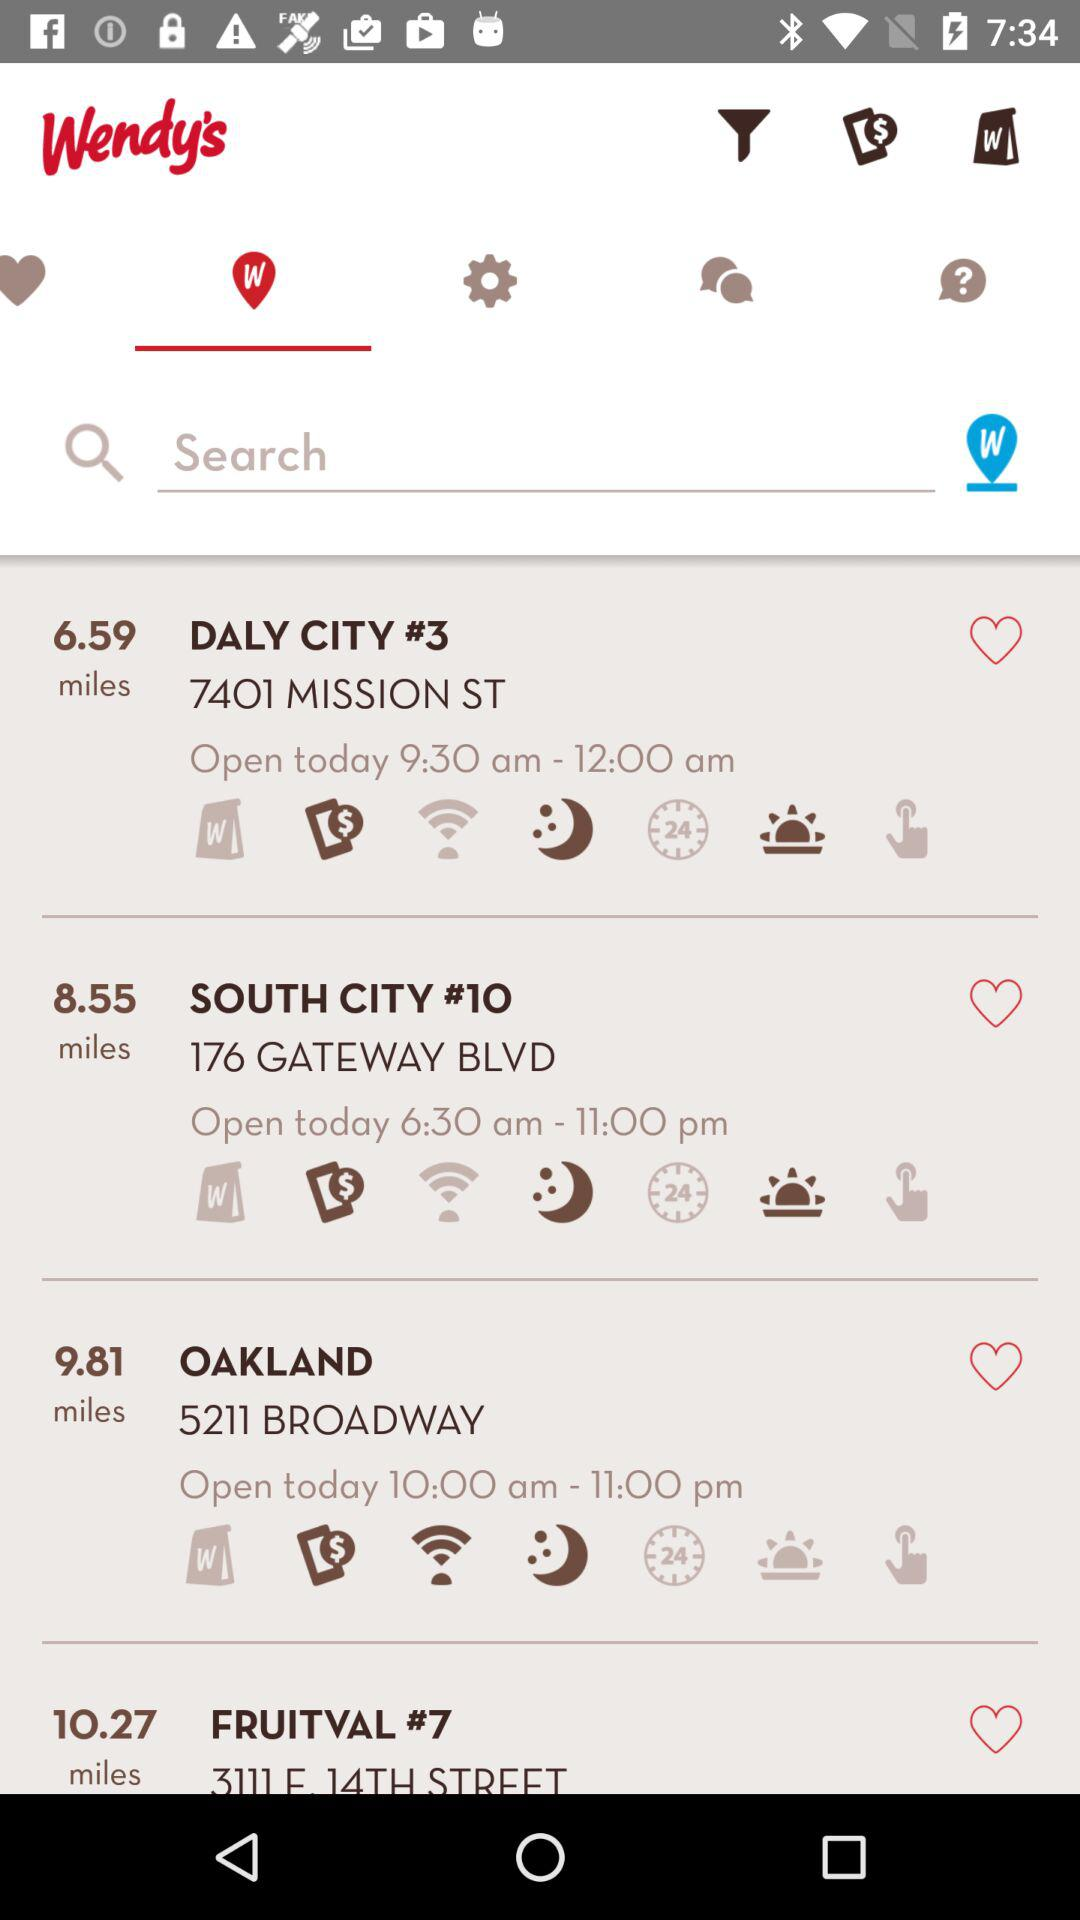What is the opening and closing time of Oakland? The opening and closing times of Oakland are 10:00 AM and 11:00 PM respectively. 